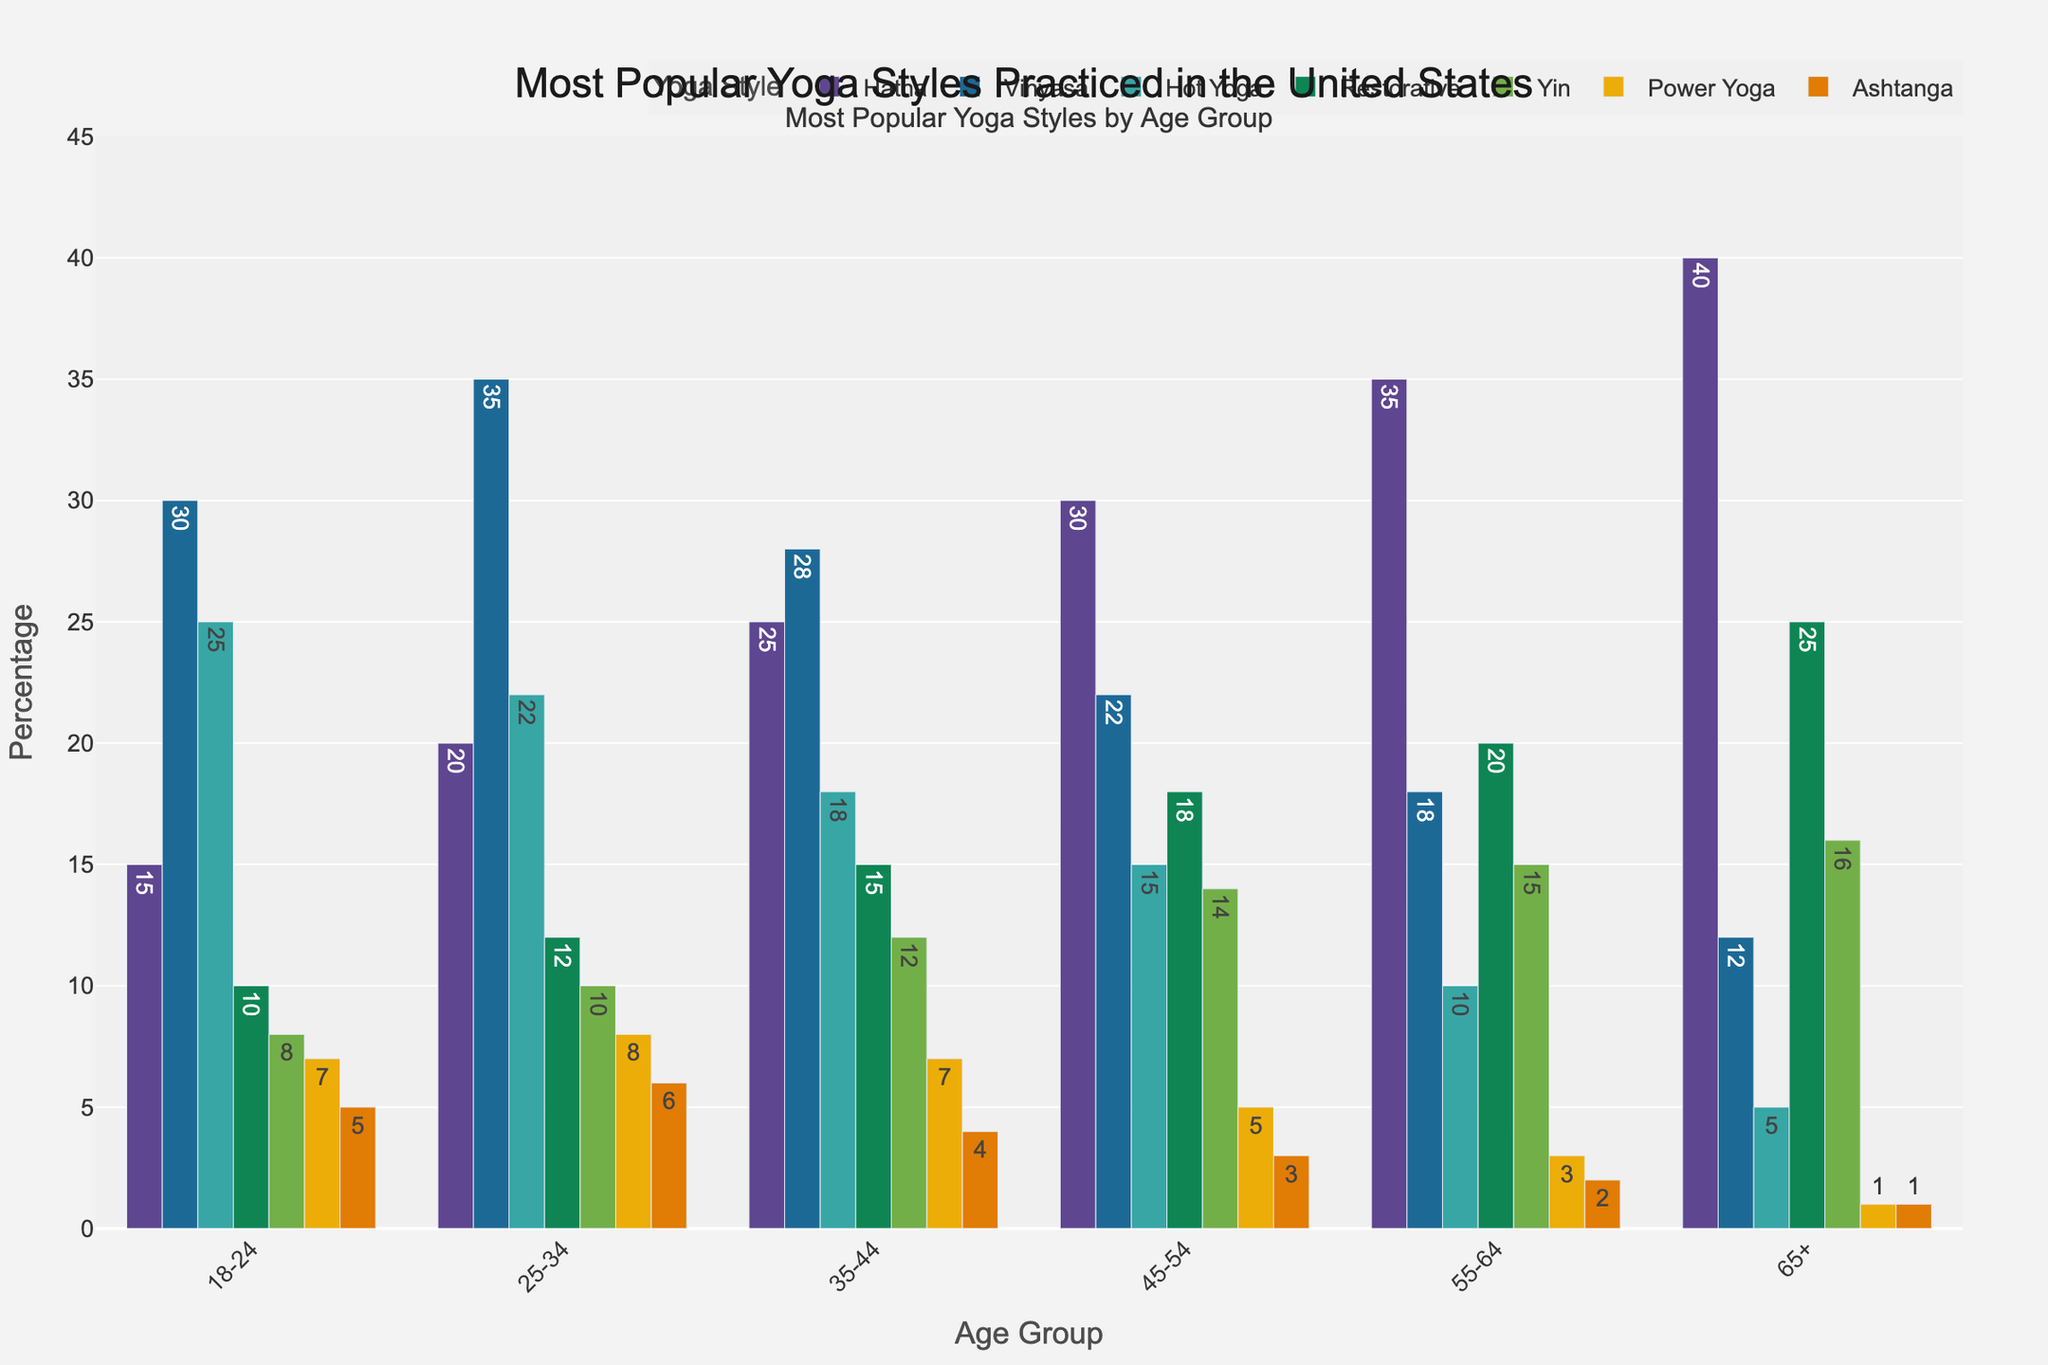Which age group practices Restorative Yoga the most? By looking at the bars for Restorative Yoga across all age groups, the tallest bar corresponds to the 65+ age group.
Answer: 65+ What's the total number of people practicing any yoga style within the 45-54 age group? Add the values for each yoga style within the 45-54 age group: 30 (Hatha) + 22 (Vinyasa) + 15 (Hot Yoga) + 18 (Restorative) + 14 (Yin) + 5 (Power Yoga) + 3 (Ashtanga) = 107
Answer: 107 Which yoga style is least popular among the 18-24 age group? By comparing the heights of the bars for the 18-24 age group, Ashtanga has the smallest value.
Answer: Ashtanga How many more people in the 55-64 age group practice Hatha Yoga compared to Vinyasa? From the 55-64 age group values: 35 (Hatha) - 18 (Vinyasa) = 17
Answer: 17 What is the average number of people practicing Hot Yoga across all age groups? Sum the values of Hot Yoga and then divide by the number of age groups: (25 + 22 + 18 + 15 + 10 + 5) / 6 = 95 / 6 ≈ 15.83
Answer: 15.83 Which age group has the highest diversity in yoga style participation? The 18-24 age group has less variation in bar heights, while the 65+ age group shows a more significant difference between the numbers for each style, suggesting higher diversity. By observing, the 65+ age group demonstrates the widest range from 40 (Hatha) to 1 (Ashtanga).
Answer: 65+ Which yoga style has the highest overall number of practitioners across all age groups? Sum the values for each yoga style and compare: Hatha: 165, Vinyasa: 145, Hot Yoga: 95, Restorative: 100, Yin: 75, Power Yoga: 31, Ashtanga: 21. Hatha has the highest total.
Answer: Hatha Between the 35-44 and 45-54 age groups, which one practices Yin Yoga more? Compare the values for Yin Yoga: 12 (35-44) vs. 14 (45-54). The 45-54 age group practices more Yin Yoga.
Answer: 45-54 